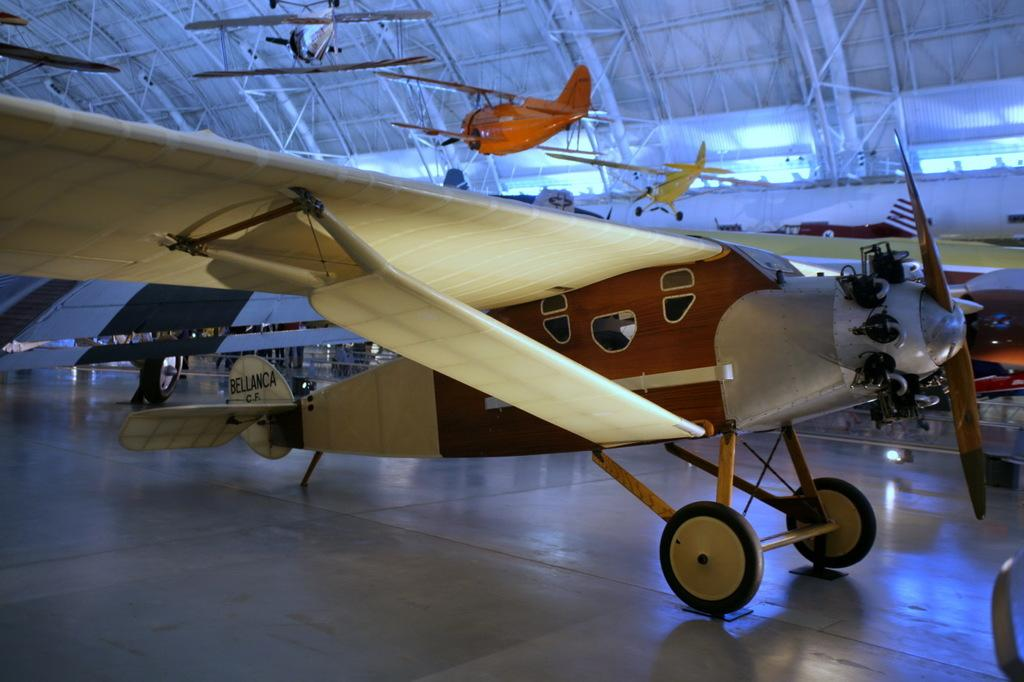What is the main subject of the image? The main subject of the image is airplanes. Where are the airplanes located in the image? The airplanes are in the center of the image. What can be seen in the background of the image? There is a wall and a roof in the background of the image. Are there any other airplanes visible in the image? Yes, there are airplanes in different colors in the background of the image. Are there any spiders crawling on the airplanes in the image? There is no mention of spiders in the image, so we cannot determine if they are present or not. 